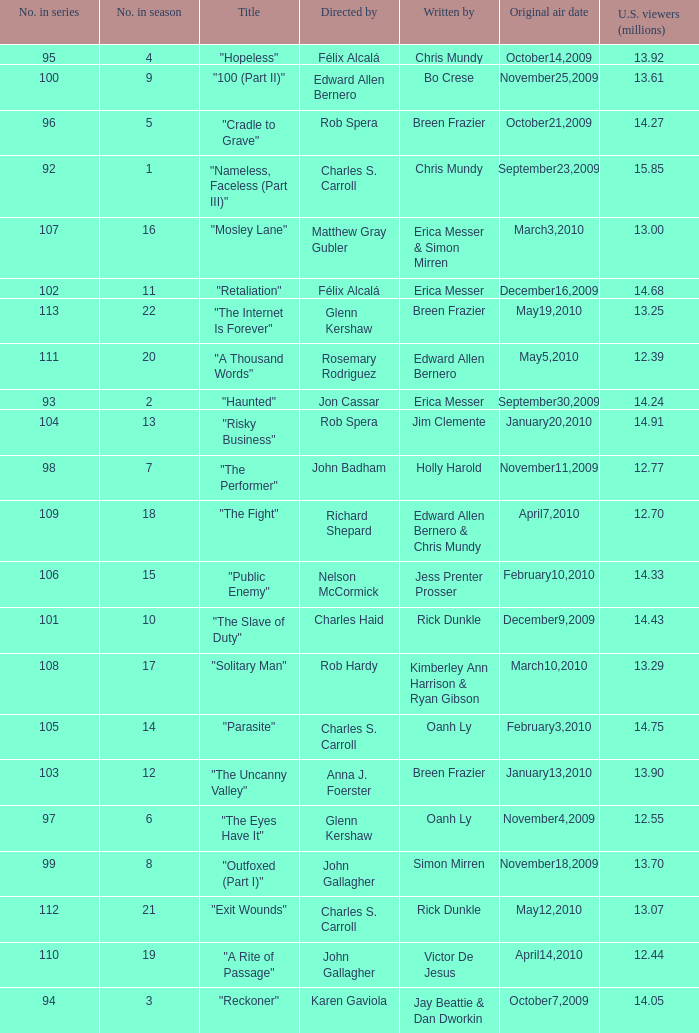What number(s) in the series was written by bo crese? 100.0. Give me the full table as a dictionary. {'header': ['No. in series', 'No. in season', 'Title', 'Directed by', 'Written by', 'Original air date', 'U.S. viewers (millions)'], 'rows': [['95', '4', '"Hopeless"', 'Félix Alcalá', 'Chris Mundy', 'October14,2009', '13.92'], ['100', '9', '"100 (Part II)"', 'Edward Allen Bernero', 'Bo Crese', 'November25,2009', '13.61'], ['96', '5', '"Cradle to Grave"', 'Rob Spera', 'Breen Frazier', 'October21,2009', '14.27'], ['92', '1', '"Nameless, Faceless (Part III)"', 'Charles S. Carroll', 'Chris Mundy', 'September23,2009', '15.85'], ['107', '16', '"Mosley Lane"', 'Matthew Gray Gubler', 'Erica Messer & Simon Mirren', 'March3,2010', '13.00'], ['102', '11', '"Retaliation"', 'Félix Alcalá', 'Erica Messer', 'December16,2009', '14.68'], ['113', '22', '"The Internet Is Forever"', 'Glenn Kershaw', 'Breen Frazier', 'May19,2010', '13.25'], ['111', '20', '"A Thousand Words"', 'Rosemary Rodriguez', 'Edward Allen Bernero', 'May5,2010', '12.39'], ['93', '2', '"Haunted"', 'Jon Cassar', 'Erica Messer', 'September30,2009', '14.24'], ['104', '13', '"Risky Business"', 'Rob Spera', 'Jim Clemente', 'January20,2010', '14.91'], ['98', '7', '"The Performer"', 'John Badham', 'Holly Harold', 'November11,2009', '12.77'], ['109', '18', '"The Fight"', 'Richard Shepard', 'Edward Allen Bernero & Chris Mundy', 'April7,2010', '12.70'], ['106', '15', '"Public Enemy"', 'Nelson McCormick', 'Jess Prenter Prosser', 'February10,2010', '14.33'], ['101', '10', '"The Slave of Duty"', 'Charles Haid', 'Rick Dunkle', 'December9,2009', '14.43'], ['108', '17', '"Solitary Man"', 'Rob Hardy', 'Kimberley Ann Harrison & Ryan Gibson', 'March10,2010', '13.29'], ['105', '14', '"Parasite"', 'Charles S. Carroll', 'Oanh Ly', 'February3,2010', '14.75'], ['103', '12', '"The Uncanny Valley"', 'Anna J. Foerster', 'Breen Frazier', 'January13,2010', '13.90'], ['97', '6', '"The Eyes Have It"', 'Glenn Kershaw', 'Oanh Ly', 'November4,2009', '12.55'], ['99', '8', '"Outfoxed (Part I)"', 'John Gallagher', 'Simon Mirren', 'November18,2009', '13.70'], ['112', '21', '"Exit Wounds"', 'Charles S. Carroll', 'Rick Dunkle', 'May12,2010', '13.07'], ['110', '19', '"A Rite of Passage"', 'John Gallagher', 'Victor De Jesus', 'April14,2010', '12.44'], ['94', '3', '"Reckoner"', 'Karen Gaviola', 'Jay Beattie & Dan Dworkin', 'October7,2009', '14.05']]} 